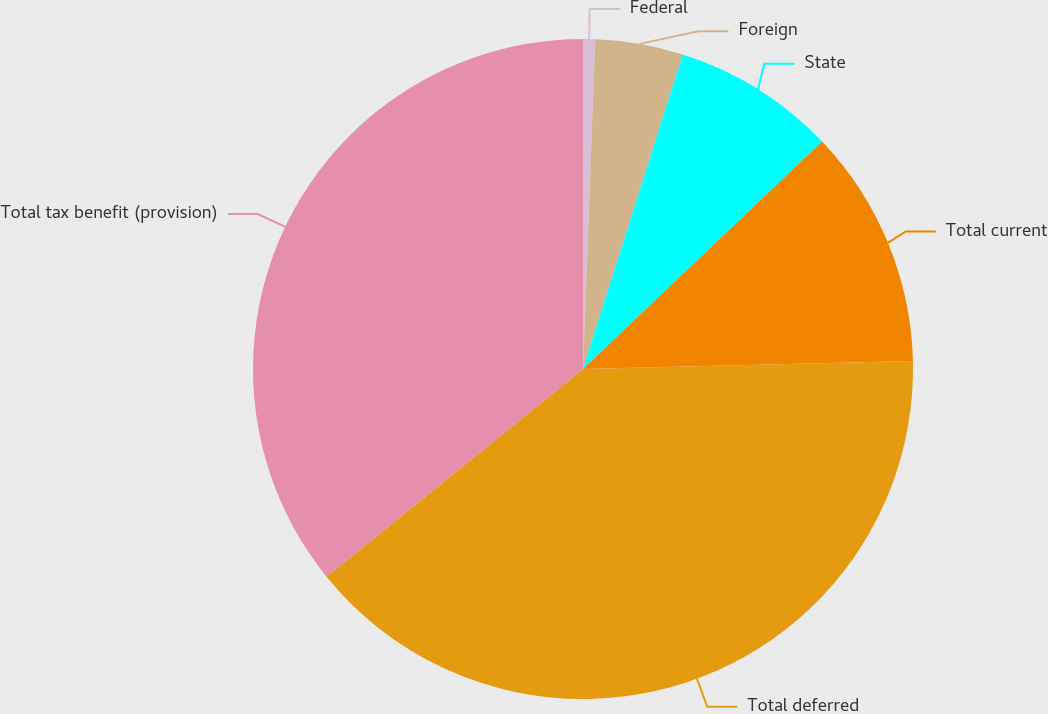Convert chart to OTSL. <chart><loc_0><loc_0><loc_500><loc_500><pie_chart><fcel>Federal<fcel>Foreign<fcel>State<fcel>Total current<fcel>Total deferred<fcel>Total tax benefit (provision)<nl><fcel>0.59%<fcel>4.3%<fcel>8.01%<fcel>11.72%<fcel>39.55%<fcel>35.84%<nl></chart> 